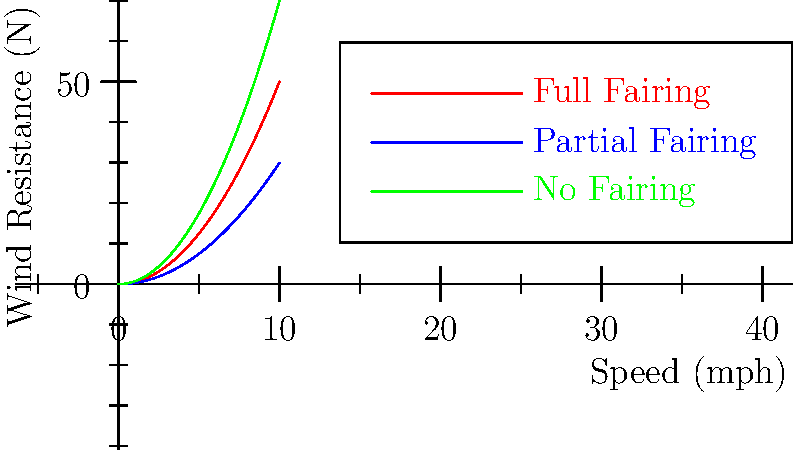Based on the aerodynamic diagram showing wind resistance for different motorcycle fairing designs, which fairing type would be most beneficial for reducing fatigue during long-distance touring at high speeds? To answer this question, we need to analyze the graph and understand the relationship between wind resistance and speed for different fairing designs:

1. The graph shows three curves representing wind resistance (in Newtons) vs. speed (in mph) for three fairing designs: full fairing, partial fairing, and no fairing.

2. The relationship between wind resistance (F) and speed (v) is generally given by the equation:

   $$F = \frac{1}{2} \rho C_d A v^2$$

   where $\rho$ is air density, $C_d$ is the drag coefficient, and A is the frontal area.

3. The curves on the graph are parabolic, which is consistent with the quadratic relationship between force and velocity in the equation above.

4. Comparing the three curves:
   - The green curve (no fairing) has the steepest slope, indicating the highest wind resistance at any given speed.
   - The red curve (full fairing) has the least steep slope, indicating the lowest wind resistance at any given speed.
   - The blue curve (partial fairing) falls between the other two.

5. For long-distance touring, especially at high speeds, lower wind resistance is beneficial because:
   - It reduces the force the rider must overcome, leading to less fatigue.
   - It improves fuel efficiency, allowing for longer distances between refueling stops.
   - It provides better stability and control in windy conditions.

6. Therefore, the full fairing design, represented by the red curve with the lowest wind resistance, would be most beneficial for reducing fatigue during long-distance touring at high speeds.
Answer: Full fairing 